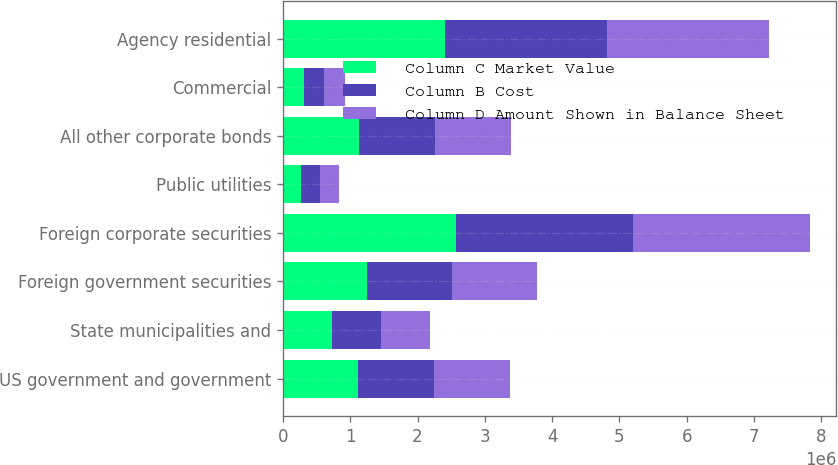Convert chart. <chart><loc_0><loc_0><loc_500><loc_500><stacked_bar_chart><ecel><fcel>US government and government<fcel>State municipalities and<fcel>Foreign government securities<fcel>Foreign corporate securities<fcel>Public utilities<fcel>All other corporate bonds<fcel>Commercial<fcel>Agency residential<nl><fcel>Column C Market Value<fcel>1.11521e+06<fcel>723938<fcel>1.25418e+06<fcel>2.56571e+06<fcel>272946<fcel>1.13032e+06<fcel>308827<fcel>2.4159e+06<nl><fcel>Column B Cost<fcel>1.13032e+06<fcel>729984<fcel>1.25816e+06<fcel>2.63198e+06<fcel>277978<fcel>1.13032e+06<fcel>306932<fcel>2.40547e+06<nl><fcel>Column D Amount Shown in Balance Sheet<fcel>1.13032e+06<fcel>729984<fcel>1.25816e+06<fcel>2.63198e+06<fcel>277978<fcel>1.13032e+06<fcel>306932<fcel>2.40547e+06<nl></chart> 